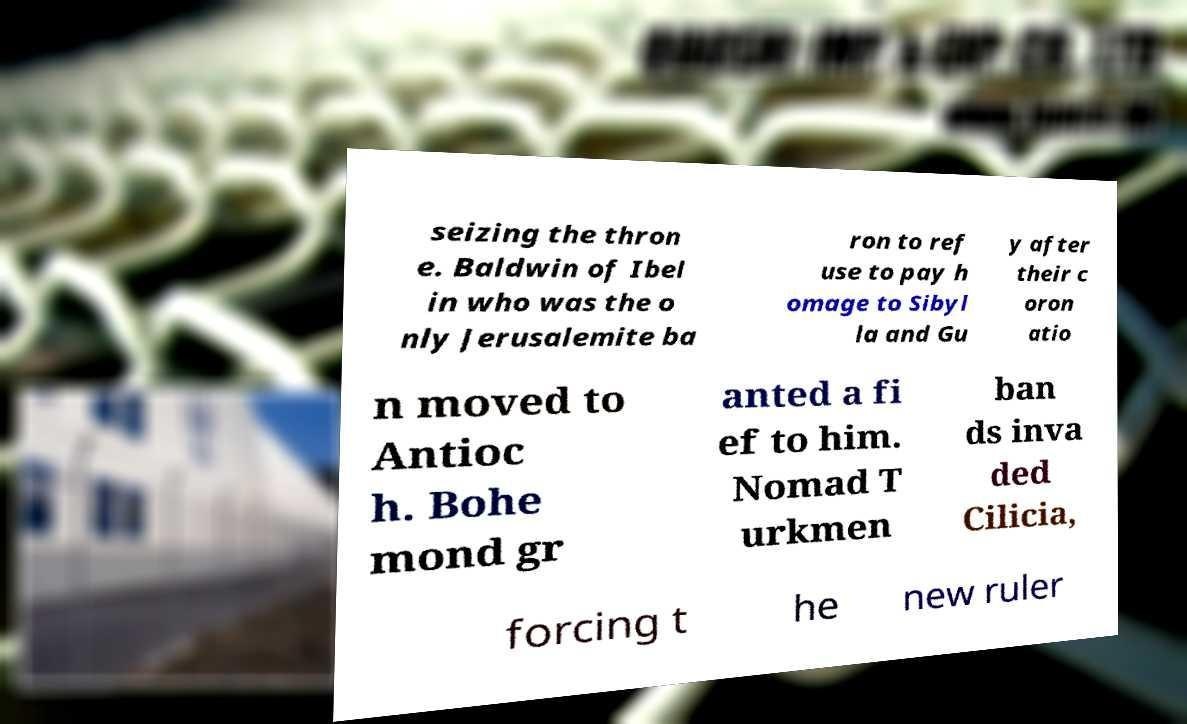Could you extract and type out the text from this image? seizing the thron e. Baldwin of Ibel in who was the o nly Jerusalemite ba ron to ref use to pay h omage to Sibyl la and Gu y after their c oron atio n moved to Antioc h. Bohe mond gr anted a fi ef to him. Nomad T urkmen ban ds inva ded Cilicia, forcing t he new ruler 